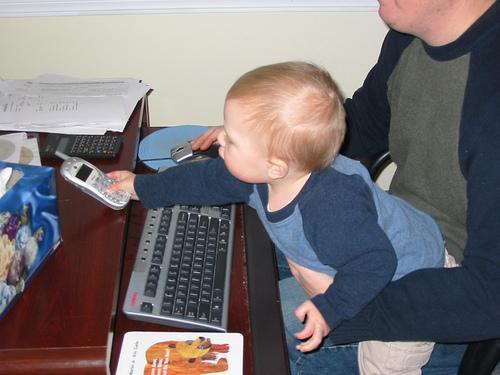How many people can you see?
Give a very brief answer. 2. 